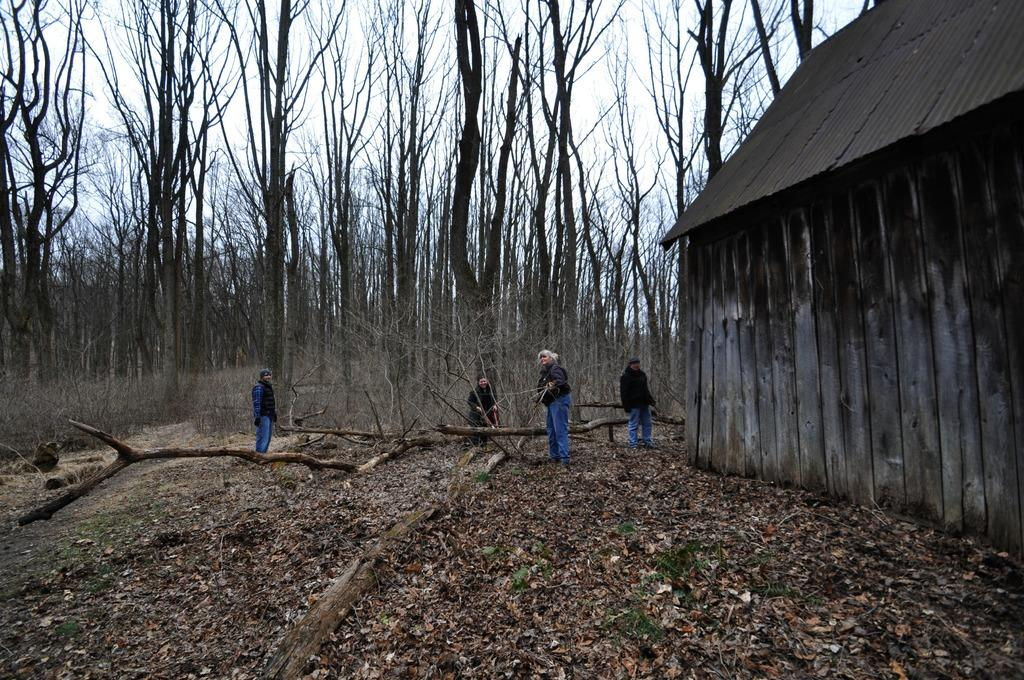What type of surface can be seen in the image? There is ground visible in the image. What objects are made of wood in the image? There are wooden logs and a wooden house in the image. What type of vegetation is present in the image? There are leaves and trees in the image. How many persons are on the ground in the image? There are persons on the ground in the image. What is visible in the background of the image? The sky is visible in the background of the image. Where is the doctor located in the image? There is no doctor present in the image. What type of map can be seen in the image? There is no map present in the image. 